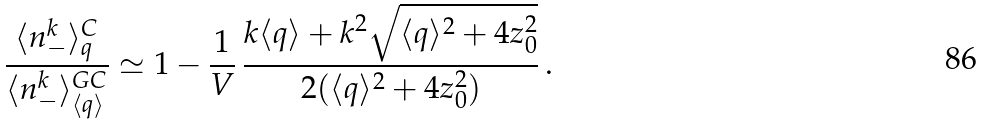<formula> <loc_0><loc_0><loc_500><loc_500>\frac { \langle n _ { - } ^ { k } \rangle _ { q } ^ { C } } { \langle { n _ { - } ^ { k } } \rangle ^ { G C } _ { \langle q \rangle } } \simeq 1 - \frac { 1 } { V } \, \frac { k \langle q \rangle + k ^ { 2 } \sqrt { \langle q \rangle ^ { 2 } + 4 z _ { 0 } ^ { 2 } } } { 2 ( \langle q \rangle ^ { 2 } + 4 z _ { 0 } ^ { 2 } ) } \, .</formula> 